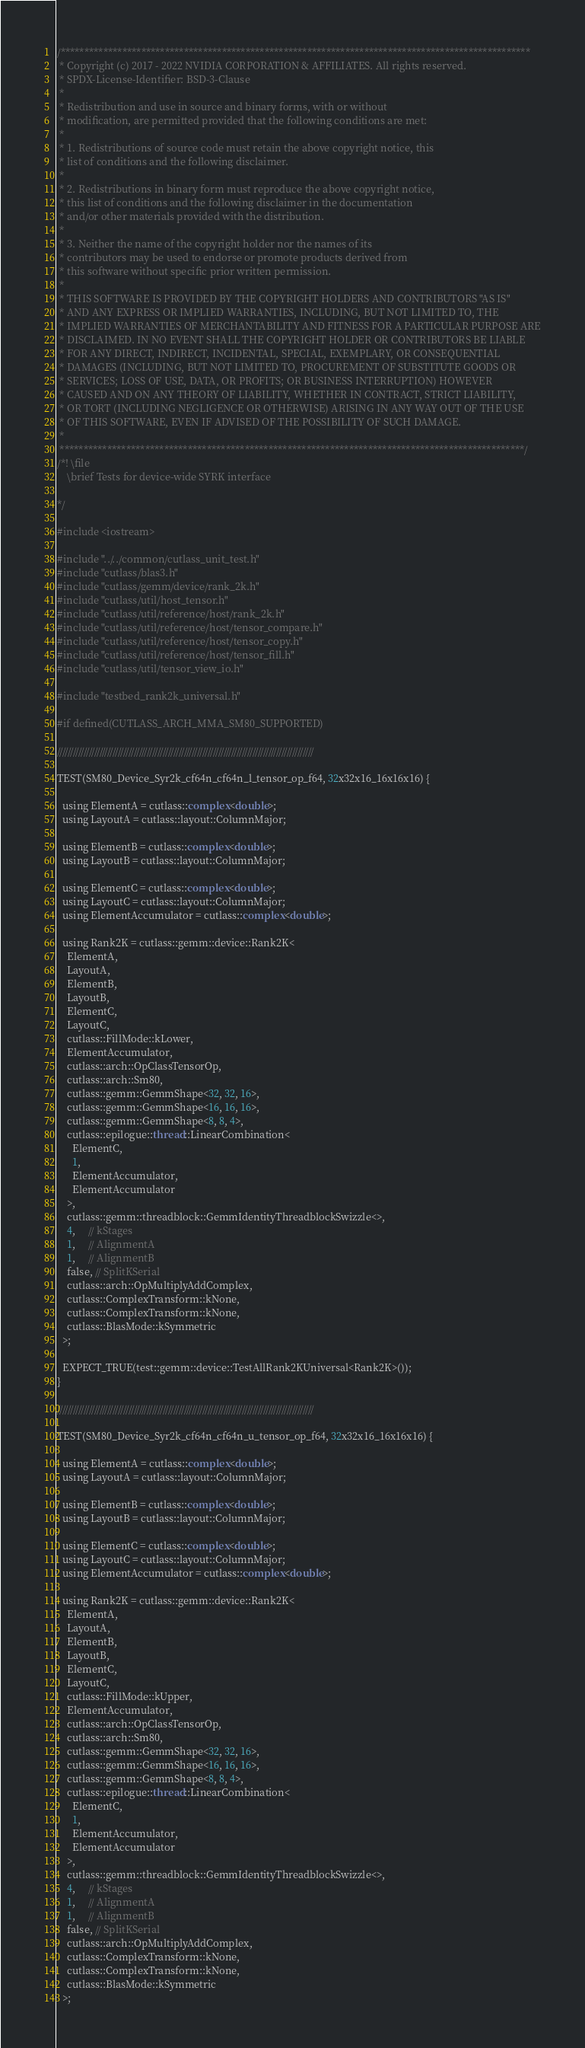Convert code to text. <code><loc_0><loc_0><loc_500><loc_500><_Cuda_>/***************************************************************************************************
 * Copyright (c) 2017 - 2022 NVIDIA CORPORATION & AFFILIATES. All rights reserved.
 * SPDX-License-Identifier: BSD-3-Clause
 *
 * Redistribution and use in source and binary forms, with or without
 * modification, are permitted provided that the following conditions are met:
 *
 * 1. Redistributions of source code must retain the above copyright notice, this
 * list of conditions and the following disclaimer.
 *
 * 2. Redistributions in binary form must reproduce the above copyright notice,
 * this list of conditions and the following disclaimer in the documentation
 * and/or other materials provided with the distribution.
 *
 * 3. Neither the name of the copyright holder nor the names of its
 * contributors may be used to endorse or promote products derived from
 * this software without specific prior written permission.
 *
 * THIS SOFTWARE IS PROVIDED BY THE COPYRIGHT HOLDERS AND CONTRIBUTORS "AS IS"
 * AND ANY EXPRESS OR IMPLIED WARRANTIES, INCLUDING, BUT NOT LIMITED TO, THE
 * IMPLIED WARRANTIES OF MERCHANTABILITY AND FITNESS FOR A PARTICULAR PURPOSE ARE
 * DISCLAIMED. IN NO EVENT SHALL THE COPYRIGHT HOLDER OR CONTRIBUTORS BE LIABLE
 * FOR ANY DIRECT, INDIRECT, INCIDENTAL, SPECIAL, EXEMPLARY, OR CONSEQUENTIAL
 * DAMAGES (INCLUDING, BUT NOT LIMITED TO, PROCUREMENT OF SUBSTITUTE GOODS OR
 * SERVICES; LOSS OF USE, DATA, OR PROFITS; OR BUSINESS INTERRUPTION) HOWEVER
 * CAUSED AND ON ANY THEORY OF LIABILITY, WHETHER IN CONTRACT, STRICT LIABILITY,
 * OR TORT (INCLUDING NEGLIGENCE OR OTHERWISE) ARISING IN ANY WAY OUT OF THE USE
 * OF THIS SOFTWARE, EVEN IF ADVISED OF THE POSSIBILITY OF SUCH DAMAGE.
 *
 **************************************************************************************************/
/*! \file
    \brief Tests for device-wide SYRK interface
  
*/

#include <iostream>

#include "../../common/cutlass_unit_test.h"
#include "cutlass/blas3.h"
#include "cutlass/gemm/device/rank_2k.h"
#include "cutlass/util/host_tensor.h"
#include "cutlass/util/reference/host/rank_2k.h"
#include "cutlass/util/reference/host/tensor_compare.h"
#include "cutlass/util/reference/host/tensor_copy.h"
#include "cutlass/util/reference/host/tensor_fill.h"
#include "cutlass/util/tensor_view_io.h"

#include "testbed_rank2k_universal.h"

#if defined(CUTLASS_ARCH_MMA_SM80_SUPPORTED)

/////////////////////////////////////////////////////////////////////////////////////////////////

TEST(SM80_Device_Syr2k_cf64n_cf64n_l_tensor_op_f64, 32x32x16_16x16x16) {

  using ElementA = cutlass::complex<double>;
  using LayoutA = cutlass::layout::ColumnMajor;

  using ElementB = cutlass::complex<double>;
  using LayoutB = cutlass::layout::ColumnMajor;

  using ElementC = cutlass::complex<double>;
  using LayoutC = cutlass::layout::ColumnMajor;
  using ElementAccumulator = cutlass::complex<double>;

  using Rank2K = cutlass::gemm::device::Rank2K<
    ElementA,
    LayoutA,
    ElementB,
    LayoutB,
    ElementC,
    LayoutC,
    cutlass::FillMode::kLower,
    ElementAccumulator,
    cutlass::arch::OpClassTensorOp,
    cutlass::arch::Sm80,
    cutlass::gemm::GemmShape<32, 32, 16>,
    cutlass::gemm::GemmShape<16, 16, 16>,
    cutlass::gemm::GemmShape<8, 8, 4>,
    cutlass::epilogue::thread::LinearCombination<
      ElementC,
      1,
      ElementAccumulator,
      ElementAccumulator
    >,
    cutlass::gemm::threadblock::GemmIdentityThreadblockSwizzle<>,
    4,     // kStages 
    1,     // AlignmentA
    1,     // AlignmentB
    false, // SplitKSerial
    cutlass::arch::OpMultiplyAddComplex,
    cutlass::ComplexTransform::kNone,
    cutlass::ComplexTransform::kNone,
    cutlass::BlasMode::kSymmetric
  >;

  EXPECT_TRUE(test::gemm::device::TestAllRank2KUniversal<Rank2K>());
}

/////////////////////////////////////////////////////////////////////////////////////////////////

TEST(SM80_Device_Syr2k_cf64n_cf64n_u_tensor_op_f64, 32x32x16_16x16x16) {

  using ElementA = cutlass::complex<double>;
  using LayoutA = cutlass::layout::ColumnMajor;

  using ElementB = cutlass::complex<double>;
  using LayoutB = cutlass::layout::ColumnMajor;

  using ElementC = cutlass::complex<double>;
  using LayoutC = cutlass::layout::ColumnMajor;
  using ElementAccumulator = cutlass::complex<double>;

  using Rank2K = cutlass::gemm::device::Rank2K<
    ElementA,
    LayoutA,
    ElementB,
    LayoutB,
    ElementC,
    LayoutC,
    cutlass::FillMode::kUpper,
    ElementAccumulator,
    cutlass::arch::OpClassTensorOp,
    cutlass::arch::Sm80,
    cutlass::gemm::GemmShape<32, 32, 16>,
    cutlass::gemm::GemmShape<16, 16, 16>,
    cutlass::gemm::GemmShape<8, 8, 4>,
    cutlass::epilogue::thread::LinearCombination<
      ElementC,
      1,
      ElementAccumulator,
      ElementAccumulator
    >,
    cutlass::gemm::threadblock::GemmIdentityThreadblockSwizzle<>,
    4,     // kStages 
    1,     // AlignmentA
    1,     // AlignmentB
    false, // SplitKSerial
    cutlass::arch::OpMultiplyAddComplex,
    cutlass::ComplexTransform::kNone,
    cutlass::ComplexTransform::kNone,
    cutlass::BlasMode::kSymmetric
  >;
</code> 